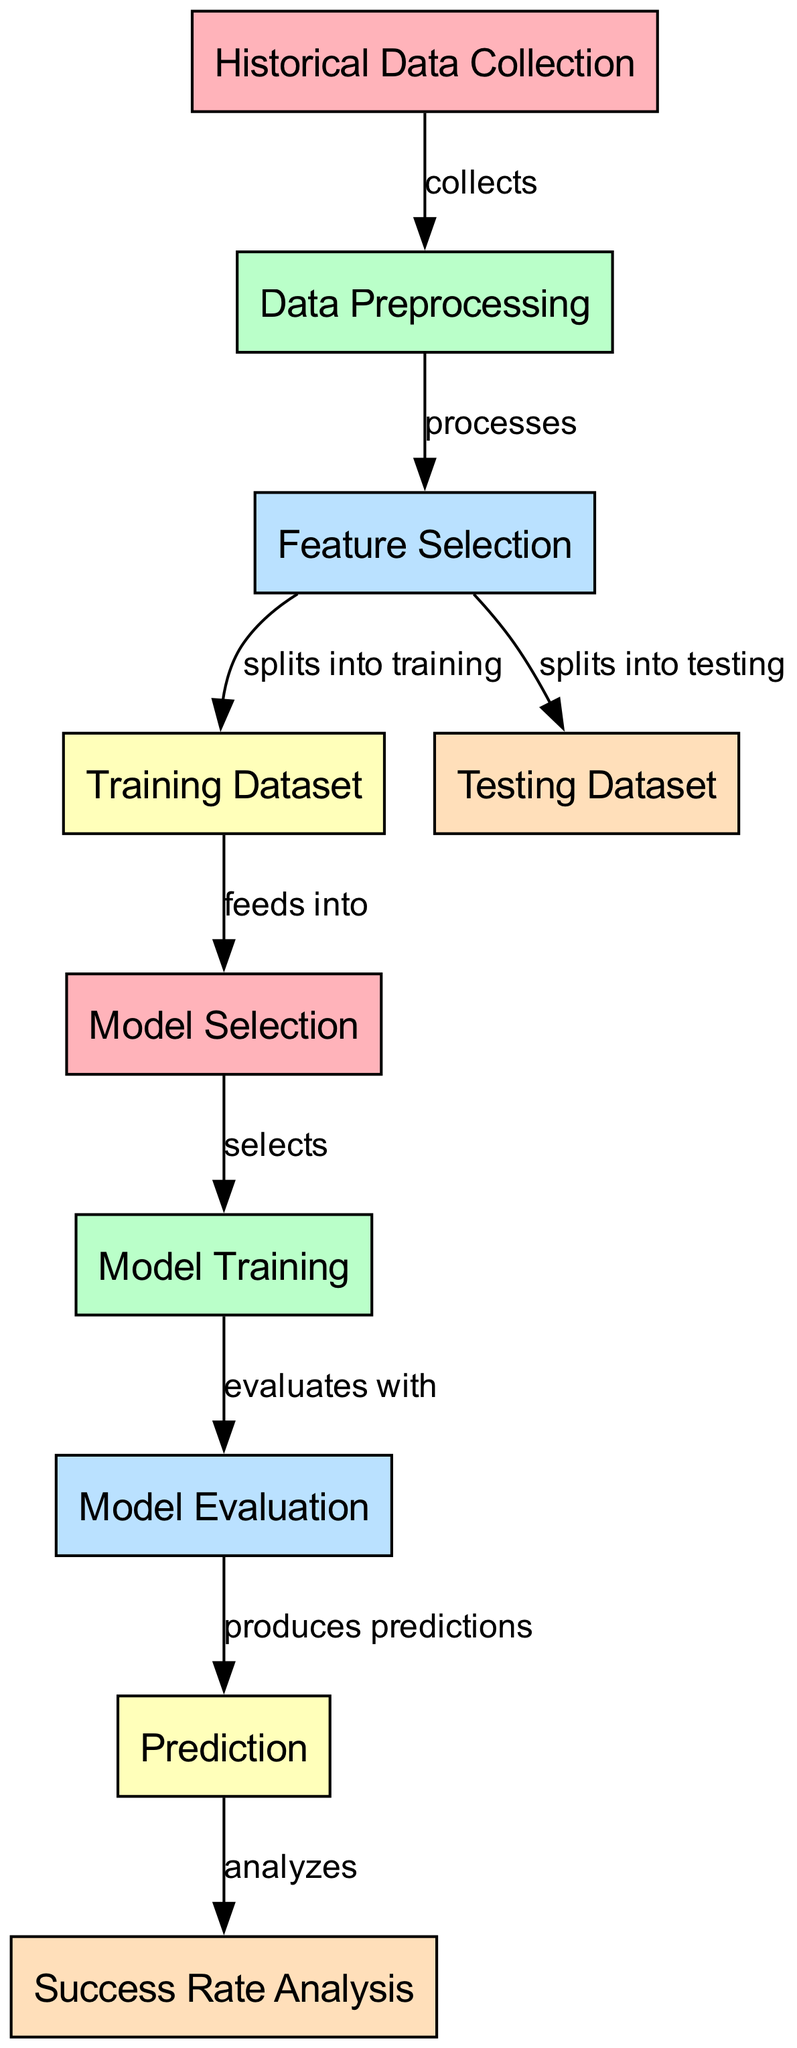What is the first step in the diagram? The first step in the diagram is "Historical Data Collection," which is the initial node that represents the gathering of past data about grant applications.
Answer: Historical Data Collection How many nodes are present in the diagram? The diagram contains ten distinct nodes, each representing a step in the process from data collection to success rate analysis.
Answer: 10 What does "Data Preprocessing" do? "Data Preprocessing" processes the historical data collected from the previous step, preparing it for further analysis and modeling.
Answer: processes Which node produces predictions? The "Model Evaluation" node leads to the "Prediction" node, which produces the final predictions about grant application success rates based on the evaluated model.
Answer: Prediction What is fed into the "Model Selection" node? The "Training Dataset" feeds into the "Model Selection" node, providing the data necessary to select the appropriate machine learning model for predictions.
Answer: Training Dataset Which step comes after "Model Training"? "Model Evaluation" is the step that follows "Model Training," where the performance of the trained model is evaluated on a separate dataset.
Answer: Model Evaluation What do the predictions analyze? The predictions generated in the "Prediction" node are analyzed in the "Success Rate Analysis" node to understand the potential success rates of grant applications for underrepresented artists.
Answer: analyzes What relationship exists between "Feature Selection" and "Training Dataset"? "Feature Selection" splits the preprocessed data into training and testing datasets, specifically designating which features to include in the training dataset.
Answer: splits into training What selects which model to use? The "Model Selection" node selects which machine learning model will be used for training based on the training dataset provided to it.
Answer: selects What does the process culminate in? The entire process culminates in the "Success Rate Analysis," which assesses the predicted success rates of grant applications for underrepresented artists based on the historical data and model evaluations.
Answer: Success Rate Analysis 